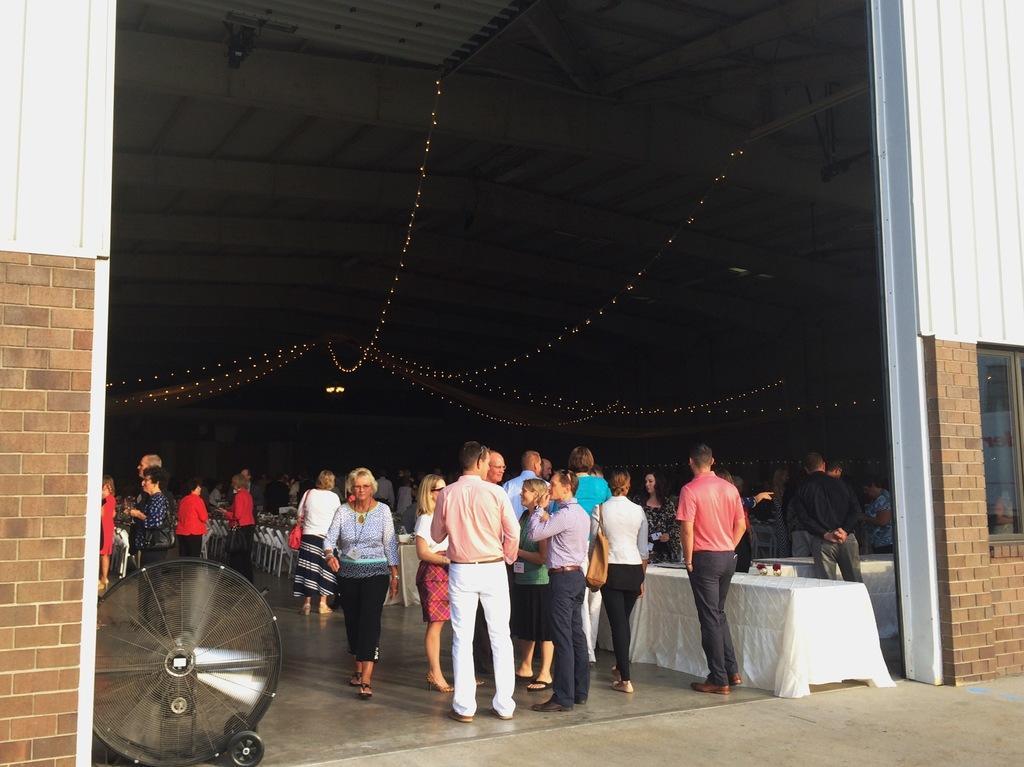How would you summarize this image in a sentence or two? The picture is taken during a function. On the left there is a fan and brick wall. In the center of the picture there are people, tables, chairs and lights. On the right it is well. 